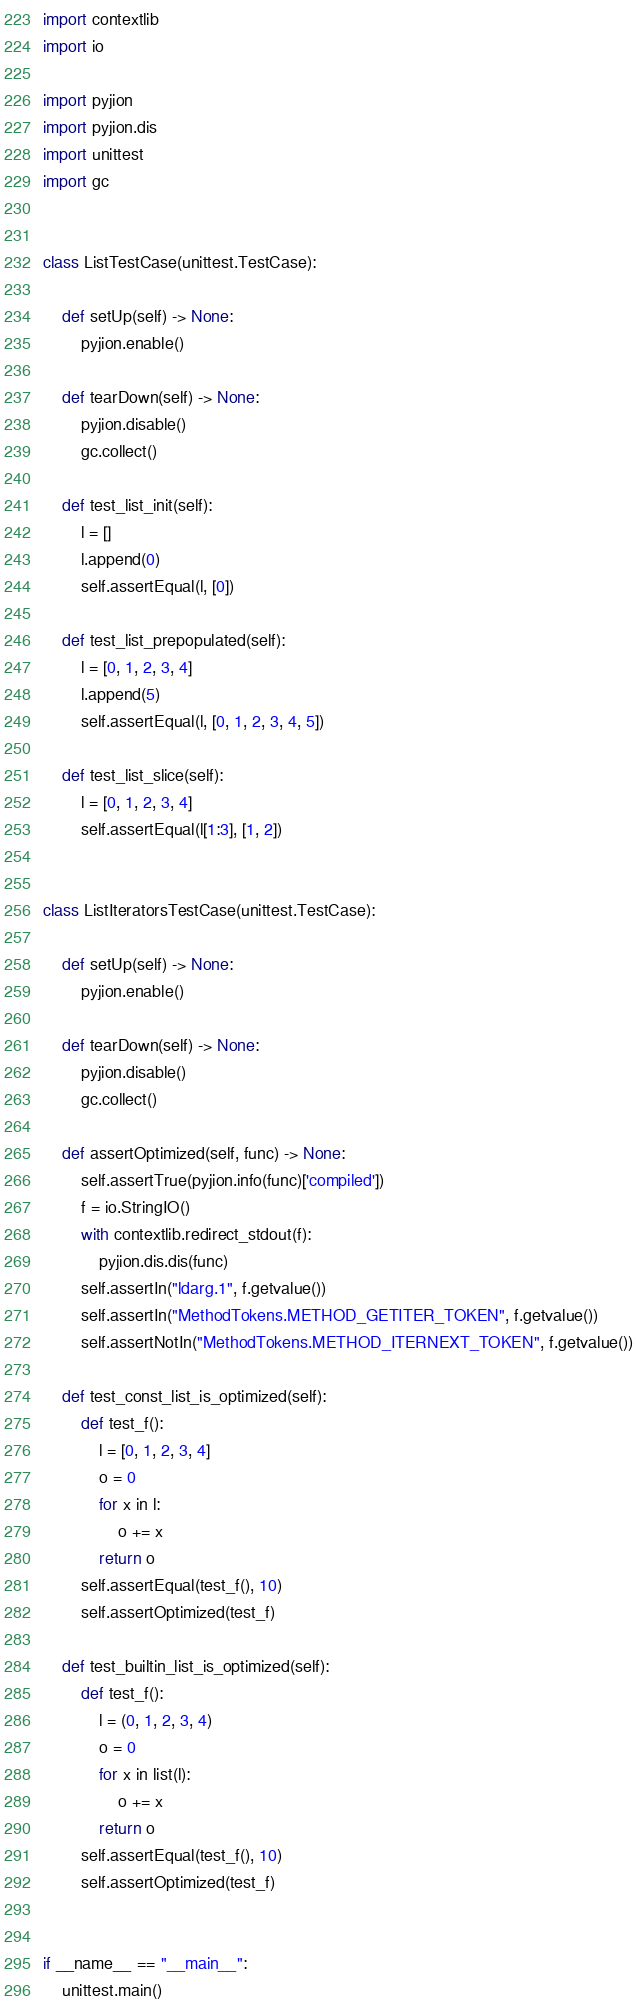Convert code to text. <code><loc_0><loc_0><loc_500><loc_500><_Python_>import contextlib
import io

import pyjion
import pyjion.dis
import unittest
import gc


class ListTestCase(unittest.TestCase):

    def setUp(self) -> None:
        pyjion.enable()

    def tearDown(self) -> None:
        pyjion.disable()
        gc.collect()

    def test_list_init(self):
        l = []
        l.append(0)
        self.assertEqual(l, [0])

    def test_list_prepopulated(self):
        l = [0, 1, 2, 3, 4]
        l.append(5)
        self.assertEqual(l, [0, 1, 2, 3, 4, 5])

    def test_list_slice(self):
        l = [0, 1, 2, 3, 4]
        self.assertEqual(l[1:3], [1, 2])


class ListIteratorsTestCase(unittest.TestCase):

    def setUp(self) -> None:
        pyjion.enable()

    def tearDown(self) -> None:
        pyjion.disable()
        gc.collect()

    def assertOptimized(self, func) -> None:
        self.assertTrue(pyjion.info(func)['compiled'])
        f = io.StringIO()
        with contextlib.redirect_stdout(f):
            pyjion.dis.dis(func)
        self.assertIn("ldarg.1", f.getvalue())
        self.assertIn("MethodTokens.METHOD_GETITER_TOKEN", f.getvalue())
        self.assertNotIn("MethodTokens.METHOD_ITERNEXT_TOKEN", f.getvalue())

    def test_const_list_is_optimized(self):
        def test_f():
            l = [0, 1, 2, 3, 4]
            o = 0
            for x in l:
                o += x
            return o
        self.assertEqual(test_f(), 10)
        self.assertOptimized(test_f)

    def test_builtin_list_is_optimized(self):
        def test_f():
            l = (0, 1, 2, 3, 4)
            o = 0
            for x in list(l):
                o += x
            return o
        self.assertEqual(test_f(), 10)
        self.assertOptimized(test_f)


if __name__ == "__main__":
    unittest.main()
</code> 